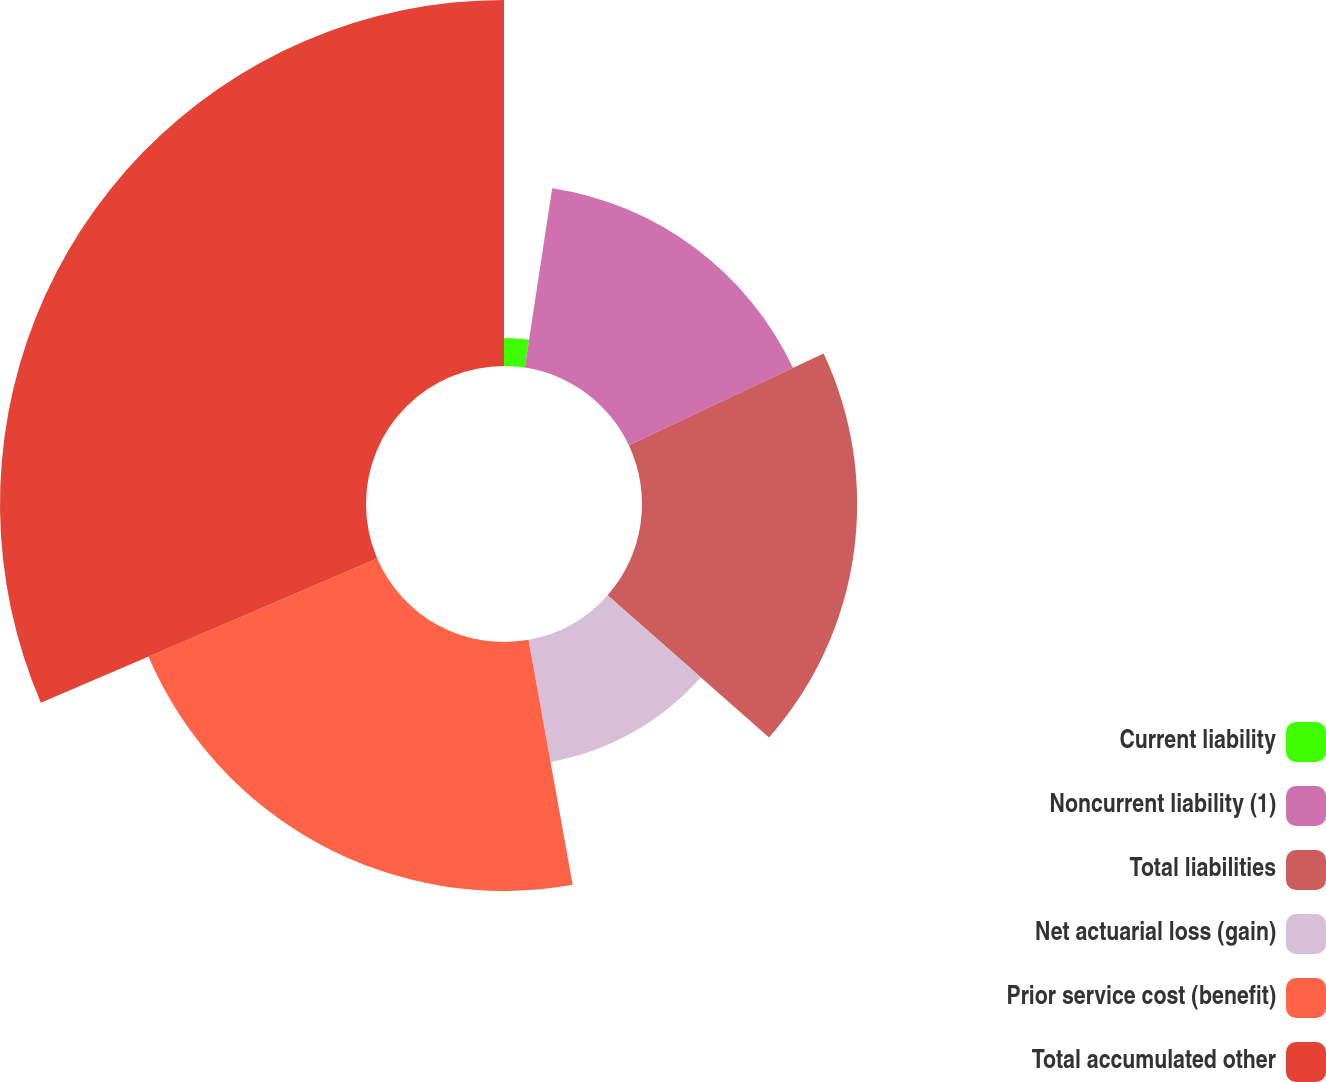<chart> <loc_0><loc_0><loc_500><loc_500><pie_chart><fcel>Current liability<fcel>Noncurrent liability (1)<fcel>Total liabilities<fcel>Net actuarial loss (gain)<fcel>Prior service cost (benefit)<fcel>Total accumulated other<nl><fcel>2.41%<fcel>15.59%<fcel>18.49%<fcel>10.67%<fcel>21.39%<fcel>31.45%<nl></chart> 